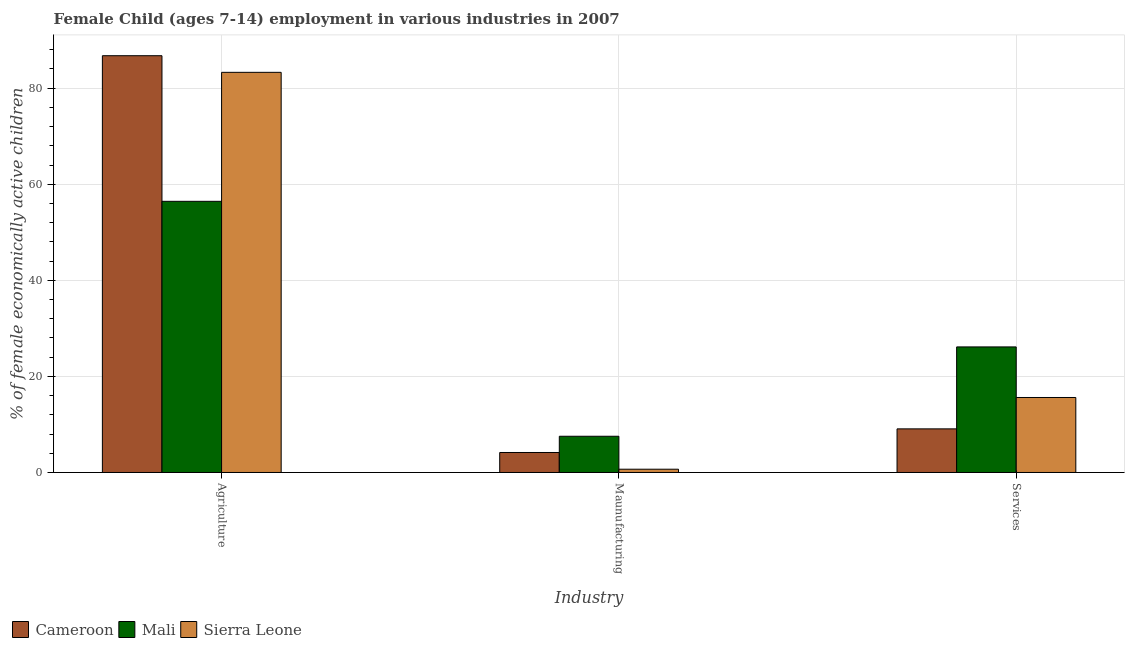How many different coloured bars are there?
Ensure brevity in your answer.  3. How many groups of bars are there?
Ensure brevity in your answer.  3. What is the label of the 1st group of bars from the left?
Make the answer very short. Agriculture. What is the percentage of economically active children in services in Sierra Leone?
Ensure brevity in your answer.  15.61. Across all countries, what is the maximum percentage of economically active children in agriculture?
Your answer should be very brief. 86.76. Across all countries, what is the minimum percentage of economically active children in agriculture?
Give a very brief answer. 56.45. In which country was the percentage of economically active children in manufacturing maximum?
Ensure brevity in your answer.  Mali. In which country was the percentage of economically active children in manufacturing minimum?
Make the answer very short. Sierra Leone. What is the total percentage of economically active children in manufacturing in the graph?
Your response must be concise. 12.38. What is the difference between the percentage of economically active children in manufacturing in Sierra Leone and that in Cameroon?
Give a very brief answer. -3.48. What is the difference between the percentage of economically active children in manufacturing in Mali and the percentage of economically active children in services in Cameroon?
Your answer should be very brief. -1.54. What is the average percentage of economically active children in services per country?
Offer a very short reply. 16.94. In how many countries, is the percentage of economically active children in manufacturing greater than 4 %?
Your answer should be very brief. 2. What is the ratio of the percentage of economically active children in agriculture in Sierra Leone to that in Mali?
Give a very brief answer. 1.48. Is the percentage of economically active children in services in Cameroon less than that in Mali?
Ensure brevity in your answer.  Yes. Is the difference between the percentage of economically active children in agriculture in Sierra Leone and Mali greater than the difference between the percentage of economically active children in manufacturing in Sierra Leone and Mali?
Provide a succinct answer. Yes. What is the difference between the highest and the second highest percentage of economically active children in services?
Give a very brief answer. 10.53. What is the difference between the highest and the lowest percentage of economically active children in services?
Your response must be concise. 17.06. In how many countries, is the percentage of economically active children in agriculture greater than the average percentage of economically active children in agriculture taken over all countries?
Ensure brevity in your answer.  2. Is the sum of the percentage of economically active children in services in Mali and Cameroon greater than the maximum percentage of economically active children in manufacturing across all countries?
Offer a very short reply. Yes. What does the 3rd bar from the left in Agriculture represents?
Keep it short and to the point. Sierra Leone. What does the 2nd bar from the right in Services represents?
Ensure brevity in your answer.  Mali. Is it the case that in every country, the sum of the percentage of economically active children in agriculture and percentage of economically active children in manufacturing is greater than the percentage of economically active children in services?
Offer a terse response. Yes. Are all the bars in the graph horizontal?
Offer a very short reply. No. What is the difference between two consecutive major ticks on the Y-axis?
Give a very brief answer. 20. Are the values on the major ticks of Y-axis written in scientific E-notation?
Your answer should be compact. No. Does the graph contain any zero values?
Your response must be concise. No. Does the graph contain grids?
Give a very brief answer. Yes. Where does the legend appear in the graph?
Offer a terse response. Bottom left. How are the legend labels stacked?
Offer a very short reply. Horizontal. What is the title of the graph?
Make the answer very short. Female Child (ages 7-14) employment in various industries in 2007. What is the label or title of the X-axis?
Provide a succinct answer. Industry. What is the label or title of the Y-axis?
Your answer should be compact. % of female economically active children. What is the % of female economically active children in Cameroon in Agriculture?
Keep it short and to the point. 86.76. What is the % of female economically active children in Mali in Agriculture?
Offer a very short reply. 56.45. What is the % of female economically active children in Sierra Leone in Agriculture?
Give a very brief answer. 83.3. What is the % of female economically active children in Cameroon in Maunufacturing?
Your answer should be very brief. 4.16. What is the % of female economically active children of Mali in Maunufacturing?
Provide a succinct answer. 7.54. What is the % of female economically active children in Sierra Leone in Maunufacturing?
Your answer should be very brief. 0.68. What is the % of female economically active children of Cameroon in Services?
Make the answer very short. 9.08. What is the % of female economically active children in Mali in Services?
Make the answer very short. 26.14. What is the % of female economically active children in Sierra Leone in Services?
Make the answer very short. 15.61. Across all Industry, what is the maximum % of female economically active children of Cameroon?
Provide a succinct answer. 86.76. Across all Industry, what is the maximum % of female economically active children in Mali?
Make the answer very short. 56.45. Across all Industry, what is the maximum % of female economically active children in Sierra Leone?
Keep it short and to the point. 83.3. Across all Industry, what is the minimum % of female economically active children of Cameroon?
Your answer should be very brief. 4.16. Across all Industry, what is the minimum % of female economically active children of Mali?
Offer a terse response. 7.54. Across all Industry, what is the minimum % of female economically active children in Sierra Leone?
Give a very brief answer. 0.68. What is the total % of female economically active children of Cameroon in the graph?
Give a very brief answer. 100. What is the total % of female economically active children of Mali in the graph?
Ensure brevity in your answer.  90.13. What is the total % of female economically active children of Sierra Leone in the graph?
Your answer should be very brief. 99.59. What is the difference between the % of female economically active children of Cameroon in Agriculture and that in Maunufacturing?
Provide a short and direct response. 82.6. What is the difference between the % of female economically active children in Mali in Agriculture and that in Maunufacturing?
Your answer should be compact. 48.91. What is the difference between the % of female economically active children in Sierra Leone in Agriculture and that in Maunufacturing?
Ensure brevity in your answer.  82.62. What is the difference between the % of female economically active children of Cameroon in Agriculture and that in Services?
Offer a terse response. 77.68. What is the difference between the % of female economically active children in Mali in Agriculture and that in Services?
Provide a succinct answer. 30.31. What is the difference between the % of female economically active children in Sierra Leone in Agriculture and that in Services?
Ensure brevity in your answer.  67.69. What is the difference between the % of female economically active children of Cameroon in Maunufacturing and that in Services?
Provide a succinct answer. -4.92. What is the difference between the % of female economically active children in Mali in Maunufacturing and that in Services?
Provide a succinct answer. -18.6. What is the difference between the % of female economically active children of Sierra Leone in Maunufacturing and that in Services?
Your answer should be very brief. -14.93. What is the difference between the % of female economically active children in Cameroon in Agriculture and the % of female economically active children in Mali in Maunufacturing?
Ensure brevity in your answer.  79.22. What is the difference between the % of female economically active children in Cameroon in Agriculture and the % of female economically active children in Sierra Leone in Maunufacturing?
Provide a short and direct response. 86.08. What is the difference between the % of female economically active children of Mali in Agriculture and the % of female economically active children of Sierra Leone in Maunufacturing?
Your answer should be very brief. 55.77. What is the difference between the % of female economically active children of Cameroon in Agriculture and the % of female economically active children of Mali in Services?
Keep it short and to the point. 60.62. What is the difference between the % of female economically active children of Cameroon in Agriculture and the % of female economically active children of Sierra Leone in Services?
Offer a very short reply. 71.15. What is the difference between the % of female economically active children in Mali in Agriculture and the % of female economically active children in Sierra Leone in Services?
Your answer should be very brief. 40.84. What is the difference between the % of female economically active children of Cameroon in Maunufacturing and the % of female economically active children of Mali in Services?
Offer a very short reply. -21.98. What is the difference between the % of female economically active children of Cameroon in Maunufacturing and the % of female economically active children of Sierra Leone in Services?
Your answer should be very brief. -11.45. What is the difference between the % of female economically active children in Mali in Maunufacturing and the % of female economically active children in Sierra Leone in Services?
Keep it short and to the point. -8.07. What is the average % of female economically active children of Cameroon per Industry?
Ensure brevity in your answer.  33.33. What is the average % of female economically active children of Mali per Industry?
Make the answer very short. 30.04. What is the average % of female economically active children of Sierra Leone per Industry?
Give a very brief answer. 33.2. What is the difference between the % of female economically active children in Cameroon and % of female economically active children in Mali in Agriculture?
Keep it short and to the point. 30.31. What is the difference between the % of female economically active children of Cameroon and % of female economically active children of Sierra Leone in Agriculture?
Your response must be concise. 3.46. What is the difference between the % of female economically active children of Mali and % of female economically active children of Sierra Leone in Agriculture?
Ensure brevity in your answer.  -26.85. What is the difference between the % of female economically active children in Cameroon and % of female economically active children in Mali in Maunufacturing?
Your response must be concise. -3.38. What is the difference between the % of female economically active children in Cameroon and % of female economically active children in Sierra Leone in Maunufacturing?
Make the answer very short. 3.48. What is the difference between the % of female economically active children of Mali and % of female economically active children of Sierra Leone in Maunufacturing?
Provide a short and direct response. 6.86. What is the difference between the % of female economically active children in Cameroon and % of female economically active children in Mali in Services?
Provide a short and direct response. -17.06. What is the difference between the % of female economically active children in Cameroon and % of female economically active children in Sierra Leone in Services?
Ensure brevity in your answer.  -6.53. What is the difference between the % of female economically active children of Mali and % of female economically active children of Sierra Leone in Services?
Give a very brief answer. 10.53. What is the ratio of the % of female economically active children of Cameroon in Agriculture to that in Maunufacturing?
Make the answer very short. 20.86. What is the ratio of the % of female economically active children in Mali in Agriculture to that in Maunufacturing?
Provide a succinct answer. 7.49. What is the ratio of the % of female economically active children of Sierra Leone in Agriculture to that in Maunufacturing?
Keep it short and to the point. 122.5. What is the ratio of the % of female economically active children of Cameroon in Agriculture to that in Services?
Your answer should be very brief. 9.56. What is the ratio of the % of female economically active children of Mali in Agriculture to that in Services?
Provide a succinct answer. 2.16. What is the ratio of the % of female economically active children in Sierra Leone in Agriculture to that in Services?
Provide a short and direct response. 5.34. What is the ratio of the % of female economically active children in Cameroon in Maunufacturing to that in Services?
Your response must be concise. 0.46. What is the ratio of the % of female economically active children in Mali in Maunufacturing to that in Services?
Your response must be concise. 0.29. What is the ratio of the % of female economically active children in Sierra Leone in Maunufacturing to that in Services?
Provide a succinct answer. 0.04. What is the difference between the highest and the second highest % of female economically active children of Cameroon?
Give a very brief answer. 77.68. What is the difference between the highest and the second highest % of female economically active children of Mali?
Keep it short and to the point. 30.31. What is the difference between the highest and the second highest % of female economically active children in Sierra Leone?
Provide a short and direct response. 67.69. What is the difference between the highest and the lowest % of female economically active children of Cameroon?
Provide a succinct answer. 82.6. What is the difference between the highest and the lowest % of female economically active children in Mali?
Ensure brevity in your answer.  48.91. What is the difference between the highest and the lowest % of female economically active children in Sierra Leone?
Keep it short and to the point. 82.62. 